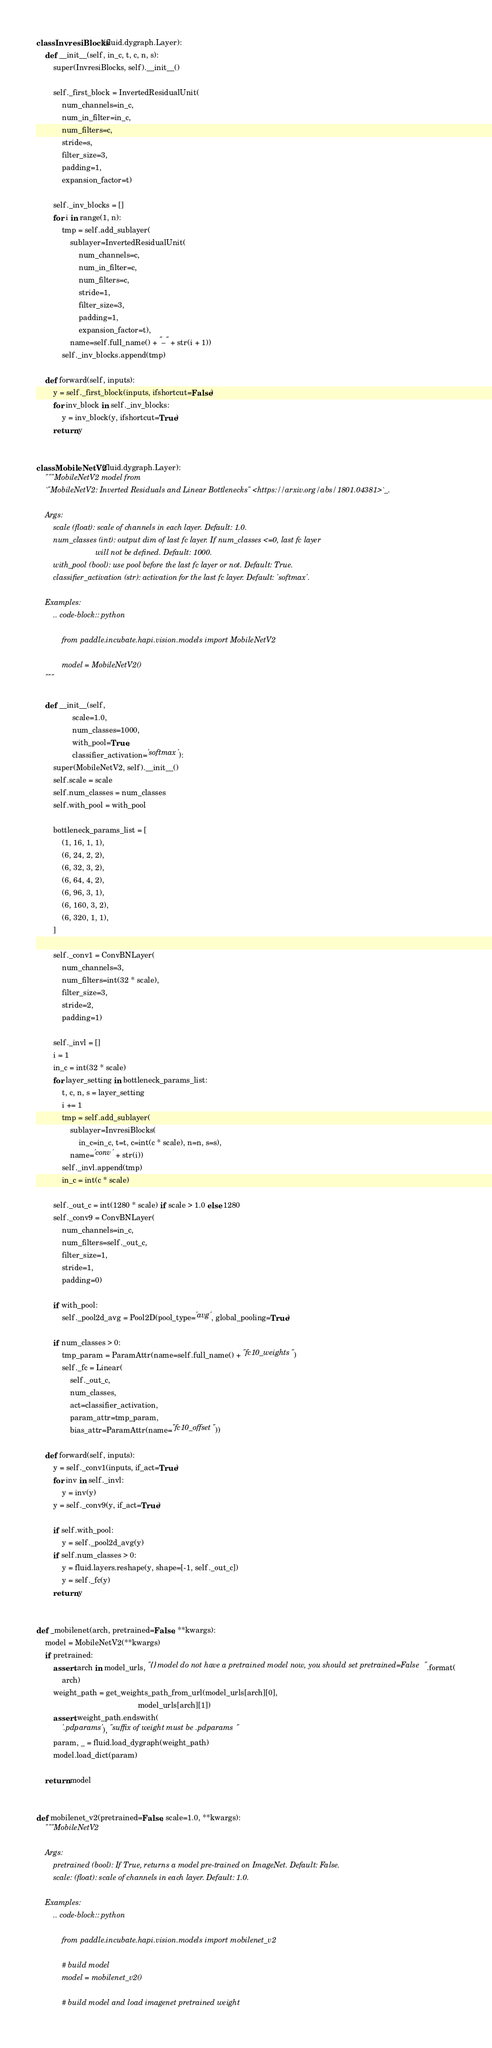<code> <loc_0><loc_0><loc_500><loc_500><_Python_>
class InvresiBlocks(fluid.dygraph.Layer):
    def __init__(self, in_c, t, c, n, s):
        super(InvresiBlocks, self).__init__()

        self._first_block = InvertedResidualUnit(
            num_channels=in_c,
            num_in_filter=in_c,
            num_filters=c,
            stride=s,
            filter_size=3,
            padding=1,
            expansion_factor=t)

        self._inv_blocks = []
        for i in range(1, n):
            tmp = self.add_sublayer(
                sublayer=InvertedResidualUnit(
                    num_channels=c,
                    num_in_filter=c,
                    num_filters=c,
                    stride=1,
                    filter_size=3,
                    padding=1,
                    expansion_factor=t),
                name=self.full_name() + "_" + str(i + 1))
            self._inv_blocks.append(tmp)

    def forward(self, inputs):
        y = self._first_block(inputs, ifshortcut=False)
        for inv_block in self._inv_blocks:
            y = inv_block(y, ifshortcut=True)
        return y


class MobileNetV2(fluid.dygraph.Layer):
    """MobileNetV2 model from
    `"MobileNetV2: Inverted Residuals and Linear Bottlenecks" <https://arxiv.org/abs/1801.04381>`_.

    Args:
        scale (float): scale of channels in each layer. Default: 1.0.
        num_classes (int): output dim of last fc layer. If num_classes <=0, last fc layer 
                            will not be defined. Default: 1000.
        with_pool (bool): use pool before the last fc layer or not. Default: True.
        classifier_activation (str): activation for the last fc layer. Default: 'softmax'.

    Examples:
        .. code-block:: python

            from paddle.incubate.hapi.vision.models import MobileNetV2

            model = MobileNetV2()
    """

    def __init__(self,
                 scale=1.0,
                 num_classes=1000,
                 with_pool=True,
                 classifier_activation='softmax'):
        super(MobileNetV2, self).__init__()
        self.scale = scale
        self.num_classes = num_classes
        self.with_pool = with_pool

        bottleneck_params_list = [
            (1, 16, 1, 1),
            (6, 24, 2, 2),
            (6, 32, 3, 2),
            (6, 64, 4, 2),
            (6, 96, 3, 1),
            (6, 160, 3, 2),
            (6, 320, 1, 1),
        ]

        self._conv1 = ConvBNLayer(
            num_channels=3,
            num_filters=int(32 * scale),
            filter_size=3,
            stride=2,
            padding=1)

        self._invl = []
        i = 1
        in_c = int(32 * scale)
        for layer_setting in bottleneck_params_list:
            t, c, n, s = layer_setting
            i += 1
            tmp = self.add_sublayer(
                sublayer=InvresiBlocks(
                    in_c=in_c, t=t, c=int(c * scale), n=n, s=s),
                name='conv' + str(i))
            self._invl.append(tmp)
            in_c = int(c * scale)

        self._out_c = int(1280 * scale) if scale > 1.0 else 1280
        self._conv9 = ConvBNLayer(
            num_channels=in_c,
            num_filters=self._out_c,
            filter_size=1,
            stride=1,
            padding=0)

        if with_pool:
            self._pool2d_avg = Pool2D(pool_type='avg', global_pooling=True)

        if num_classes > 0:
            tmp_param = ParamAttr(name=self.full_name() + "fc10_weights")
            self._fc = Linear(
                self._out_c,
                num_classes,
                act=classifier_activation,
                param_attr=tmp_param,
                bias_attr=ParamAttr(name="fc10_offset"))

    def forward(self, inputs):
        y = self._conv1(inputs, if_act=True)
        for inv in self._invl:
            y = inv(y)
        y = self._conv9(y, if_act=True)

        if self.with_pool:
            y = self._pool2d_avg(y)
        if self.num_classes > 0:
            y = fluid.layers.reshape(y, shape=[-1, self._out_c])
            y = self._fc(y)
        return y


def _mobilenet(arch, pretrained=False, **kwargs):
    model = MobileNetV2(**kwargs)
    if pretrained:
        assert arch in model_urls, "{} model do not have a pretrained model now, you should set pretrained=False".format(
            arch)
        weight_path = get_weights_path_from_url(model_urls[arch][0],
                                                model_urls[arch][1])
        assert weight_path.endswith(
            '.pdparams'), "suffix of weight must be .pdparams"
        param, _ = fluid.load_dygraph(weight_path)
        model.load_dict(param)

    return model


def mobilenet_v2(pretrained=False, scale=1.0, **kwargs):
    """MobileNetV2
    
    Args:
        pretrained (bool): If True, returns a model pre-trained on ImageNet. Default: False.
        scale: (float): scale of channels in each layer. Default: 1.0.

    Examples:
        .. code-block:: python

            from paddle.incubate.hapi.vision.models import mobilenet_v2

            # build model
            model = mobilenet_v2()

            # build model and load imagenet pretrained weight</code> 